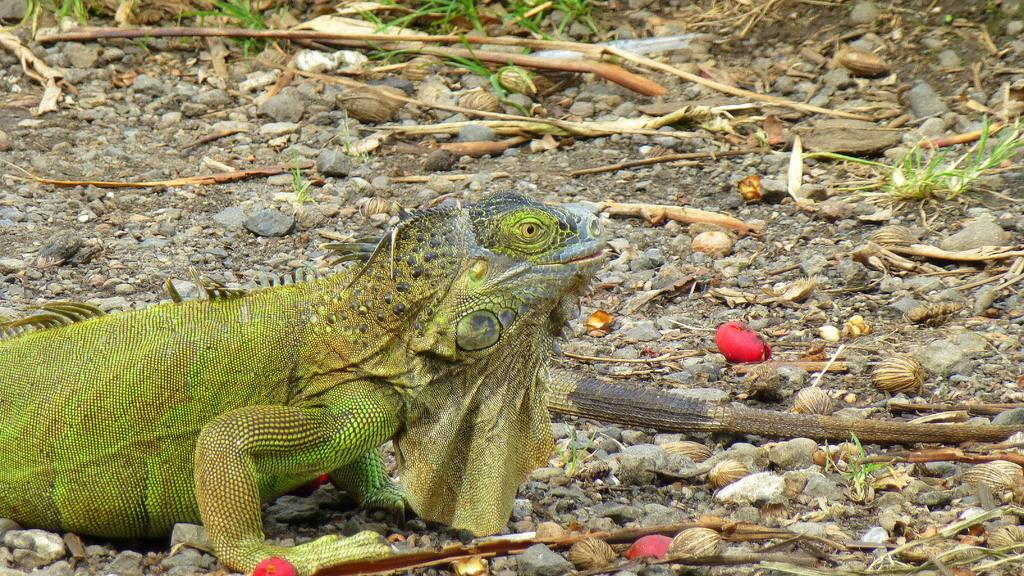Where was the image taken? The image was taken outdoors. What can be seen at the bottom of the image? There is a ground with stones and dry leaves at the bottom of the image. What animal is present in the image? There is a chameleon on the ground on the left side of the image. How much money is the chameleon holding in the image? There is no money present in the image; it features a chameleon on the ground. What type of lumber is visible in the image? There is no lumber present in the image; it features a chameleon on the ground with stones and dry leaves. 